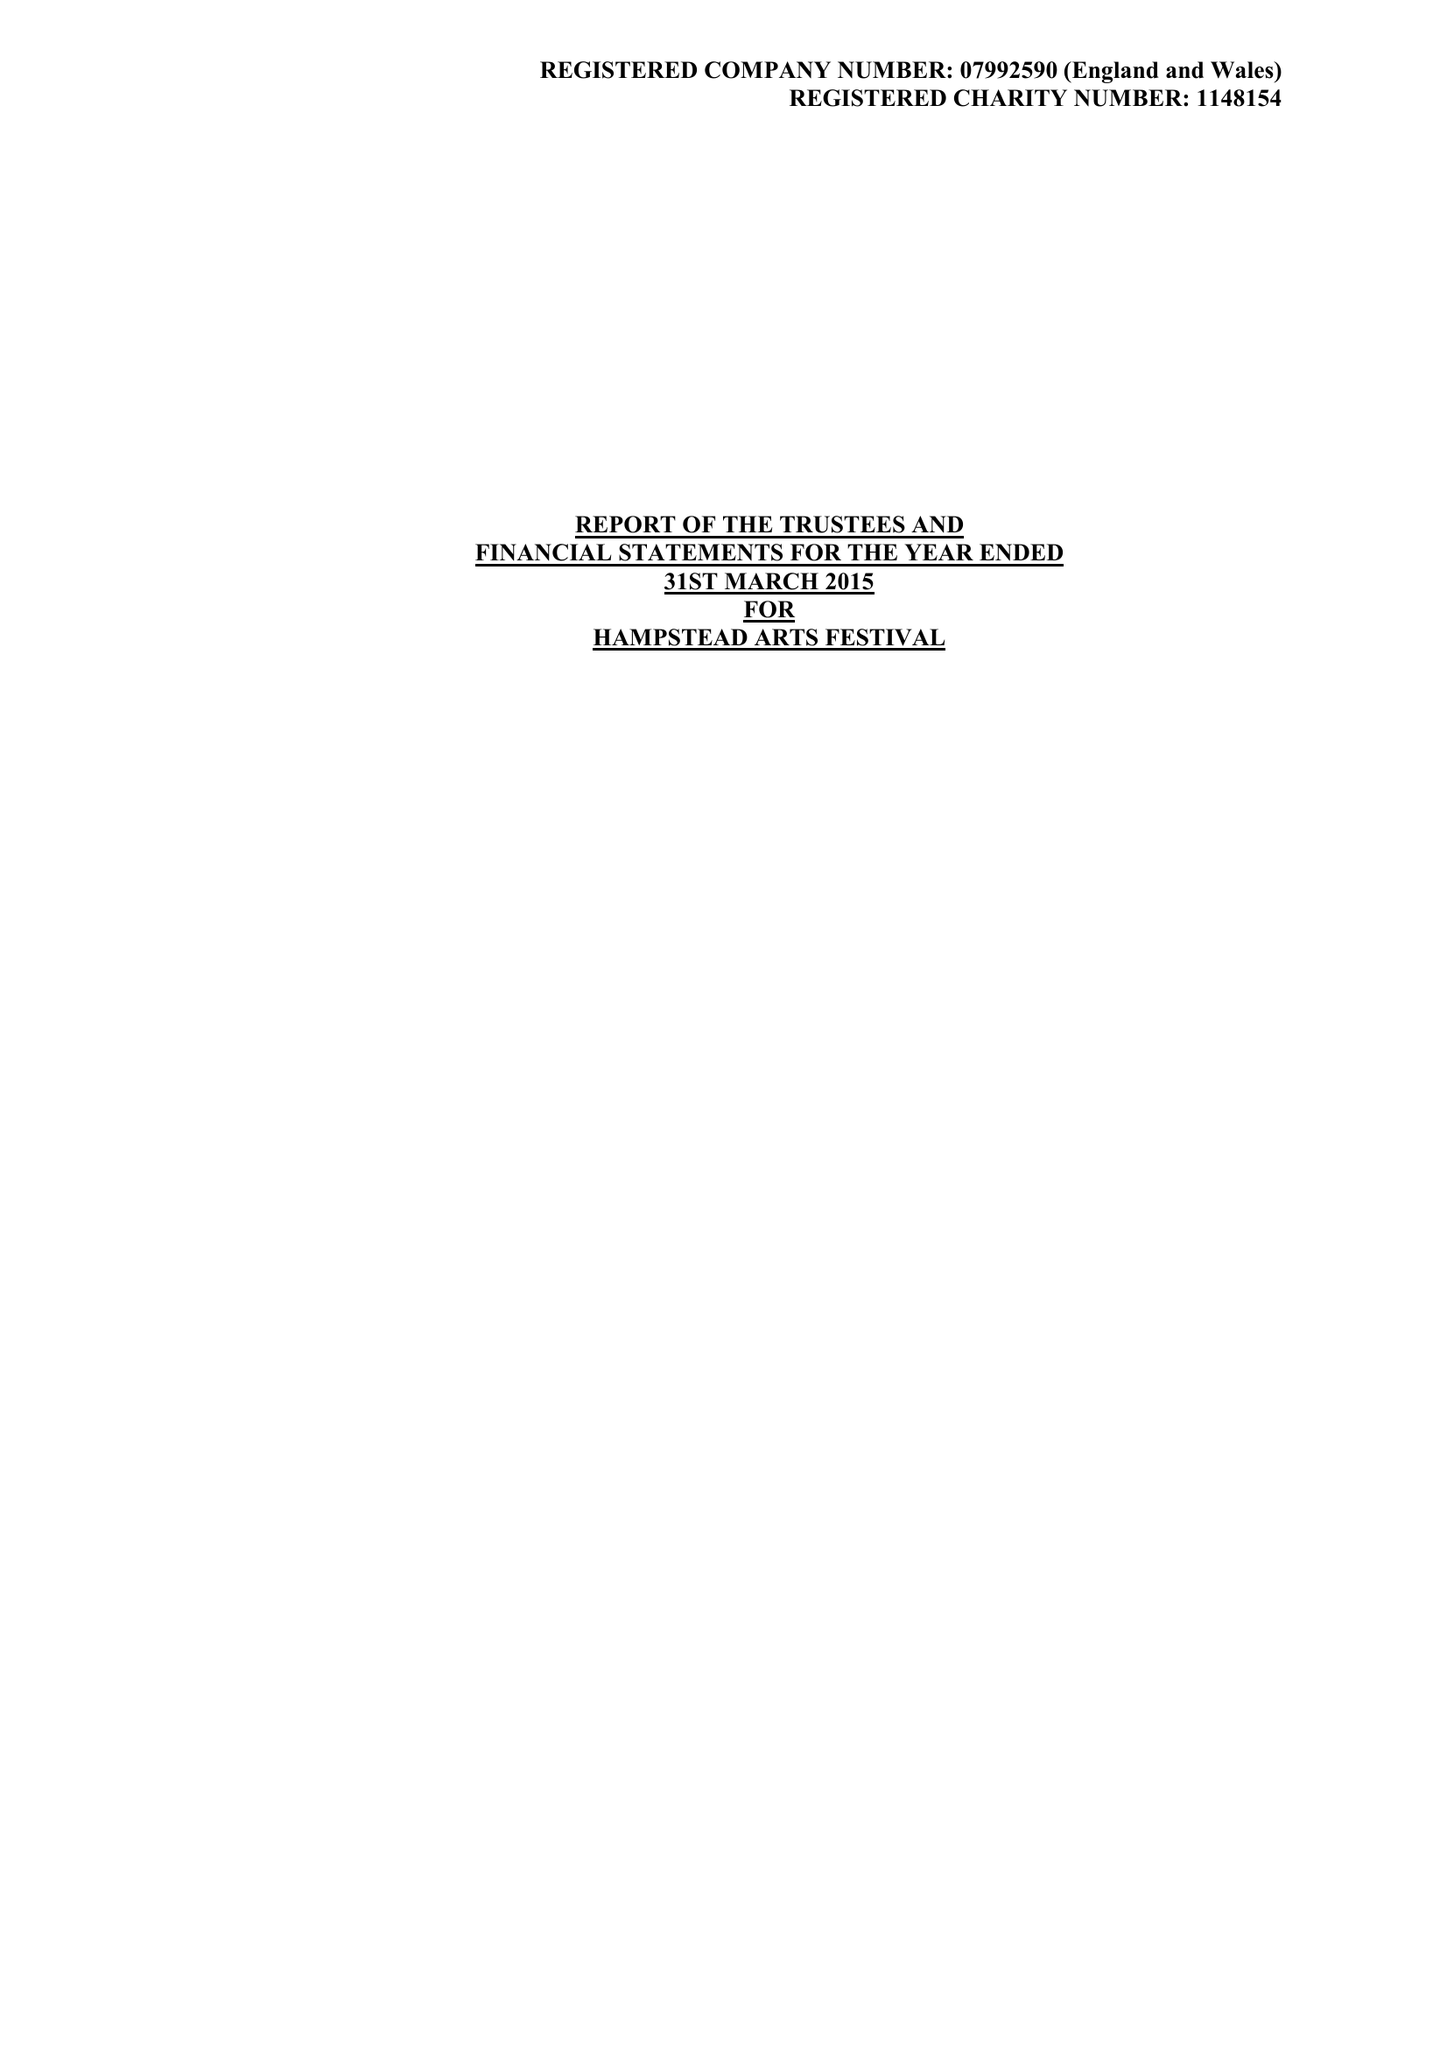What is the value for the report_date?
Answer the question using a single word or phrase. 2015-03-31 